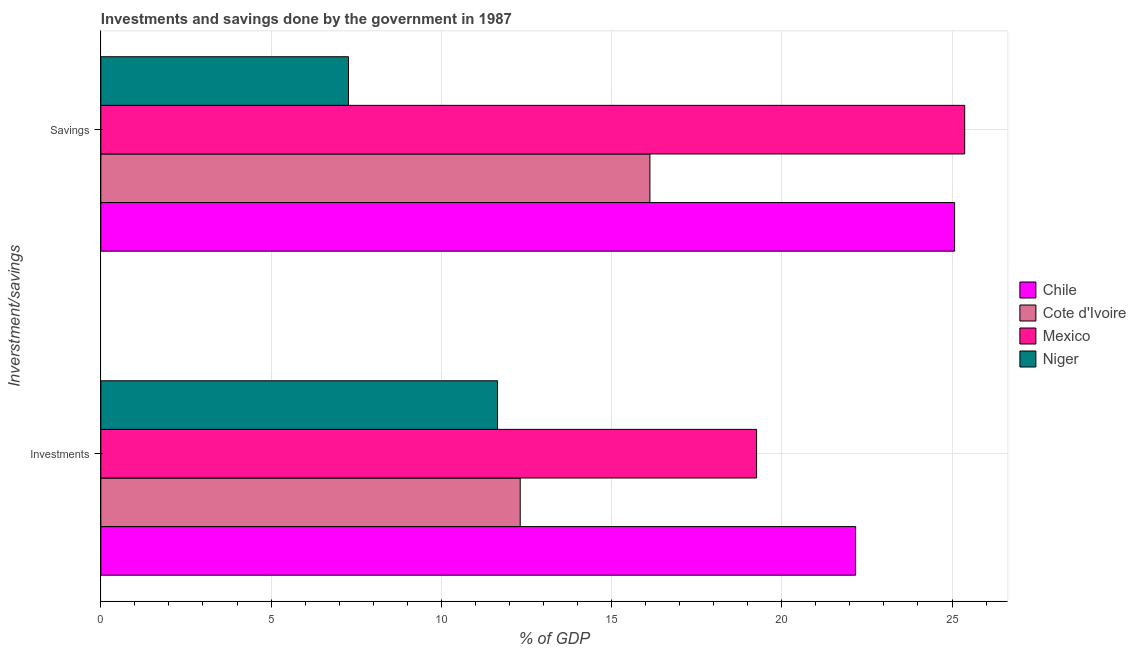How many different coloured bars are there?
Your response must be concise. 4. How many bars are there on the 2nd tick from the top?
Provide a succinct answer. 4. What is the label of the 2nd group of bars from the top?
Keep it short and to the point. Investments. What is the savings of government in Cote d'Ivoire?
Offer a very short reply. 16.13. Across all countries, what is the maximum investments of government?
Provide a short and direct response. 22.17. Across all countries, what is the minimum investments of government?
Your response must be concise. 11.65. In which country was the savings of government maximum?
Your answer should be compact. Mexico. In which country was the savings of government minimum?
Offer a very short reply. Niger. What is the total investments of government in the graph?
Your response must be concise. 65.4. What is the difference between the investments of government in Cote d'Ivoire and that in Chile?
Give a very brief answer. -9.85. What is the difference between the savings of government in Niger and the investments of government in Chile?
Keep it short and to the point. -14.9. What is the average savings of government per country?
Offer a very short reply. 18.46. What is the difference between the savings of government and investments of government in Chile?
Your response must be concise. 2.91. What is the ratio of the investments of government in Mexico to that in Chile?
Offer a terse response. 0.87. In how many countries, is the savings of government greater than the average savings of government taken over all countries?
Give a very brief answer. 2. What does the 1st bar from the top in Savings represents?
Keep it short and to the point. Niger. What does the 3rd bar from the bottom in Investments represents?
Your answer should be very brief. Mexico. Are all the bars in the graph horizontal?
Provide a short and direct response. Yes. Does the graph contain grids?
Make the answer very short. Yes. How many legend labels are there?
Make the answer very short. 4. What is the title of the graph?
Make the answer very short. Investments and savings done by the government in 1987. What is the label or title of the X-axis?
Your answer should be compact. % of GDP. What is the label or title of the Y-axis?
Offer a very short reply. Inverstment/savings. What is the % of GDP in Chile in Investments?
Your response must be concise. 22.17. What is the % of GDP in Cote d'Ivoire in Investments?
Keep it short and to the point. 12.32. What is the % of GDP of Mexico in Investments?
Your answer should be very brief. 19.26. What is the % of GDP of Niger in Investments?
Give a very brief answer. 11.65. What is the % of GDP in Chile in Savings?
Give a very brief answer. 25.08. What is the % of GDP of Cote d'Ivoire in Savings?
Ensure brevity in your answer.  16.13. What is the % of GDP of Mexico in Savings?
Your response must be concise. 25.37. What is the % of GDP of Niger in Savings?
Provide a short and direct response. 7.27. Across all Inverstment/savings, what is the maximum % of GDP in Chile?
Your response must be concise. 25.08. Across all Inverstment/savings, what is the maximum % of GDP of Cote d'Ivoire?
Your answer should be very brief. 16.13. Across all Inverstment/savings, what is the maximum % of GDP of Mexico?
Give a very brief answer. 25.37. Across all Inverstment/savings, what is the maximum % of GDP of Niger?
Offer a very short reply. 11.65. Across all Inverstment/savings, what is the minimum % of GDP of Chile?
Offer a terse response. 22.17. Across all Inverstment/savings, what is the minimum % of GDP of Cote d'Ivoire?
Your answer should be compact. 12.32. Across all Inverstment/savings, what is the minimum % of GDP of Mexico?
Ensure brevity in your answer.  19.26. Across all Inverstment/savings, what is the minimum % of GDP in Niger?
Provide a short and direct response. 7.27. What is the total % of GDP of Chile in the graph?
Your response must be concise. 47.25. What is the total % of GDP in Cote d'Ivoire in the graph?
Offer a very short reply. 28.44. What is the total % of GDP of Mexico in the graph?
Your answer should be very brief. 44.63. What is the total % of GDP in Niger in the graph?
Offer a very short reply. 18.93. What is the difference between the % of GDP in Chile in Investments and that in Savings?
Your answer should be very brief. -2.91. What is the difference between the % of GDP of Cote d'Ivoire in Investments and that in Savings?
Give a very brief answer. -3.81. What is the difference between the % of GDP of Mexico in Investments and that in Savings?
Your answer should be compact. -6.11. What is the difference between the % of GDP in Niger in Investments and that in Savings?
Give a very brief answer. 4.38. What is the difference between the % of GDP of Chile in Investments and the % of GDP of Cote d'Ivoire in Savings?
Ensure brevity in your answer.  6.04. What is the difference between the % of GDP in Chile in Investments and the % of GDP in Mexico in Savings?
Provide a succinct answer. -3.2. What is the difference between the % of GDP of Chile in Investments and the % of GDP of Niger in Savings?
Offer a very short reply. 14.9. What is the difference between the % of GDP of Cote d'Ivoire in Investments and the % of GDP of Mexico in Savings?
Your response must be concise. -13.06. What is the difference between the % of GDP of Cote d'Ivoire in Investments and the % of GDP of Niger in Savings?
Provide a succinct answer. 5.04. What is the difference between the % of GDP in Mexico in Investments and the % of GDP in Niger in Savings?
Ensure brevity in your answer.  11.99. What is the average % of GDP of Chile per Inverstment/savings?
Ensure brevity in your answer.  23.62. What is the average % of GDP of Cote d'Ivoire per Inverstment/savings?
Give a very brief answer. 14.22. What is the average % of GDP in Mexico per Inverstment/savings?
Offer a terse response. 22.32. What is the average % of GDP of Niger per Inverstment/savings?
Your response must be concise. 9.46. What is the difference between the % of GDP in Chile and % of GDP in Cote d'Ivoire in Investments?
Make the answer very short. 9.85. What is the difference between the % of GDP of Chile and % of GDP of Mexico in Investments?
Make the answer very short. 2.91. What is the difference between the % of GDP in Chile and % of GDP in Niger in Investments?
Keep it short and to the point. 10.52. What is the difference between the % of GDP in Cote d'Ivoire and % of GDP in Mexico in Investments?
Provide a succinct answer. -6.94. What is the difference between the % of GDP in Cote d'Ivoire and % of GDP in Niger in Investments?
Ensure brevity in your answer.  0.66. What is the difference between the % of GDP of Mexico and % of GDP of Niger in Investments?
Ensure brevity in your answer.  7.61. What is the difference between the % of GDP of Chile and % of GDP of Cote d'Ivoire in Savings?
Your response must be concise. 8.95. What is the difference between the % of GDP of Chile and % of GDP of Mexico in Savings?
Provide a short and direct response. -0.3. What is the difference between the % of GDP of Chile and % of GDP of Niger in Savings?
Your response must be concise. 17.8. What is the difference between the % of GDP in Cote d'Ivoire and % of GDP in Mexico in Savings?
Keep it short and to the point. -9.25. What is the difference between the % of GDP in Cote d'Ivoire and % of GDP in Niger in Savings?
Your response must be concise. 8.85. What is the difference between the % of GDP in Mexico and % of GDP in Niger in Savings?
Offer a very short reply. 18.1. What is the ratio of the % of GDP of Chile in Investments to that in Savings?
Your answer should be compact. 0.88. What is the ratio of the % of GDP of Cote d'Ivoire in Investments to that in Savings?
Offer a very short reply. 0.76. What is the ratio of the % of GDP of Mexico in Investments to that in Savings?
Give a very brief answer. 0.76. What is the ratio of the % of GDP of Niger in Investments to that in Savings?
Offer a very short reply. 1.6. What is the difference between the highest and the second highest % of GDP of Chile?
Ensure brevity in your answer.  2.91. What is the difference between the highest and the second highest % of GDP in Cote d'Ivoire?
Give a very brief answer. 3.81. What is the difference between the highest and the second highest % of GDP in Mexico?
Provide a succinct answer. 6.11. What is the difference between the highest and the second highest % of GDP in Niger?
Your answer should be compact. 4.38. What is the difference between the highest and the lowest % of GDP in Chile?
Keep it short and to the point. 2.91. What is the difference between the highest and the lowest % of GDP of Cote d'Ivoire?
Your answer should be very brief. 3.81. What is the difference between the highest and the lowest % of GDP of Mexico?
Your answer should be very brief. 6.11. What is the difference between the highest and the lowest % of GDP in Niger?
Ensure brevity in your answer.  4.38. 